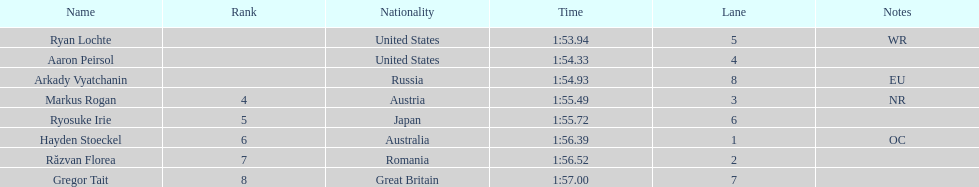Which competitor was the last to place? Gregor Tait. 